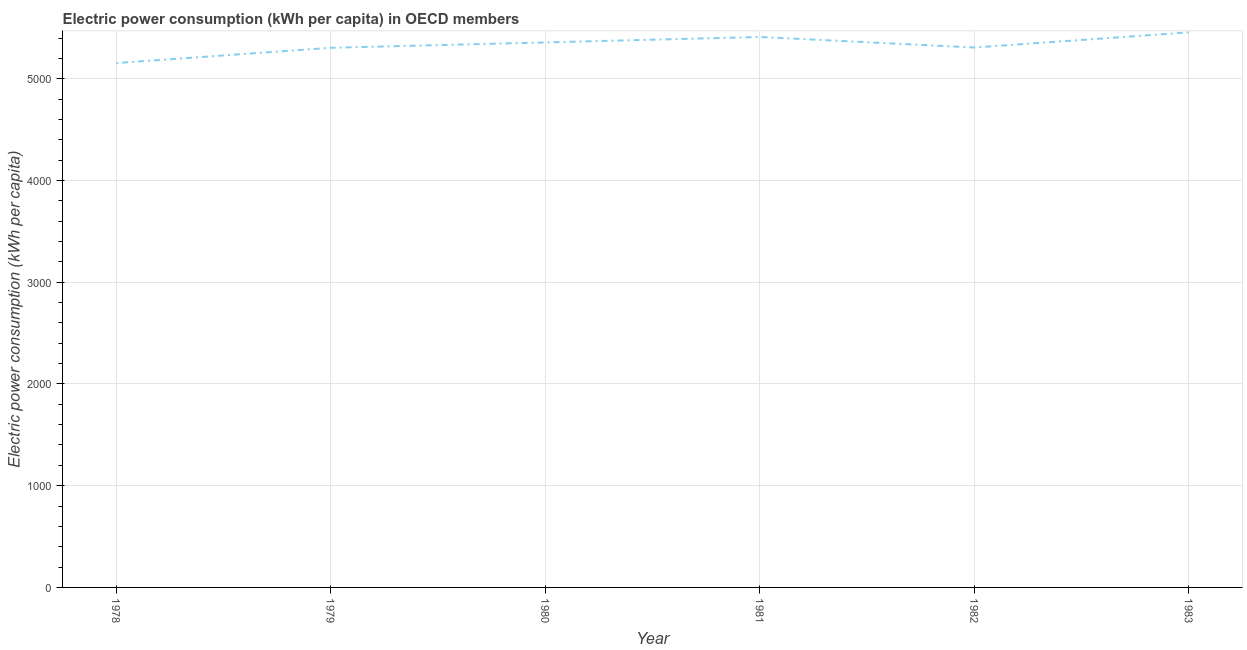What is the electric power consumption in 1982?
Your answer should be very brief. 5307.14. Across all years, what is the maximum electric power consumption?
Provide a succinct answer. 5456.01. Across all years, what is the minimum electric power consumption?
Give a very brief answer. 5153.86. In which year was the electric power consumption maximum?
Keep it short and to the point. 1983. In which year was the electric power consumption minimum?
Make the answer very short. 1978. What is the sum of the electric power consumption?
Ensure brevity in your answer.  3.20e+04. What is the difference between the electric power consumption in 1978 and 1979?
Your response must be concise. -150.58. What is the average electric power consumption per year?
Offer a terse response. 5331.56. What is the median electric power consumption?
Your answer should be very brief. 5332.1. Do a majority of the years between 1979 and 1978 (inclusive) have electric power consumption greater than 1200 kWh per capita?
Provide a succinct answer. No. What is the ratio of the electric power consumption in 1978 to that in 1982?
Keep it short and to the point. 0.97. Is the electric power consumption in 1979 less than that in 1981?
Offer a very short reply. Yes. What is the difference between the highest and the second highest electric power consumption?
Provide a succinct answer. 45.17. What is the difference between the highest and the lowest electric power consumption?
Your answer should be very brief. 302.15. How many years are there in the graph?
Your answer should be compact. 6. What is the difference between two consecutive major ticks on the Y-axis?
Offer a terse response. 1000. Does the graph contain any zero values?
Keep it short and to the point. No. Does the graph contain grids?
Ensure brevity in your answer.  Yes. What is the title of the graph?
Your response must be concise. Electric power consumption (kWh per capita) in OECD members. What is the label or title of the Y-axis?
Your answer should be compact. Electric power consumption (kWh per capita). What is the Electric power consumption (kWh per capita) of 1978?
Keep it short and to the point. 5153.86. What is the Electric power consumption (kWh per capita) of 1979?
Make the answer very short. 5304.44. What is the Electric power consumption (kWh per capita) in 1980?
Provide a succinct answer. 5357.06. What is the Electric power consumption (kWh per capita) in 1981?
Make the answer very short. 5410.84. What is the Electric power consumption (kWh per capita) of 1982?
Offer a very short reply. 5307.14. What is the Electric power consumption (kWh per capita) of 1983?
Keep it short and to the point. 5456.01. What is the difference between the Electric power consumption (kWh per capita) in 1978 and 1979?
Your response must be concise. -150.58. What is the difference between the Electric power consumption (kWh per capita) in 1978 and 1980?
Offer a terse response. -203.19. What is the difference between the Electric power consumption (kWh per capita) in 1978 and 1981?
Provide a short and direct response. -256.98. What is the difference between the Electric power consumption (kWh per capita) in 1978 and 1982?
Ensure brevity in your answer.  -153.28. What is the difference between the Electric power consumption (kWh per capita) in 1978 and 1983?
Your response must be concise. -302.15. What is the difference between the Electric power consumption (kWh per capita) in 1979 and 1980?
Offer a terse response. -52.62. What is the difference between the Electric power consumption (kWh per capita) in 1979 and 1981?
Your response must be concise. -106.4. What is the difference between the Electric power consumption (kWh per capita) in 1979 and 1982?
Provide a short and direct response. -2.7. What is the difference between the Electric power consumption (kWh per capita) in 1979 and 1983?
Provide a succinct answer. -151.57. What is the difference between the Electric power consumption (kWh per capita) in 1980 and 1981?
Ensure brevity in your answer.  -53.78. What is the difference between the Electric power consumption (kWh per capita) in 1980 and 1982?
Provide a succinct answer. 49.91. What is the difference between the Electric power consumption (kWh per capita) in 1980 and 1983?
Offer a very short reply. -98.96. What is the difference between the Electric power consumption (kWh per capita) in 1981 and 1982?
Offer a very short reply. 103.7. What is the difference between the Electric power consumption (kWh per capita) in 1981 and 1983?
Offer a terse response. -45.17. What is the difference between the Electric power consumption (kWh per capita) in 1982 and 1983?
Your answer should be very brief. -148.87. What is the ratio of the Electric power consumption (kWh per capita) in 1978 to that in 1979?
Your answer should be very brief. 0.97. What is the ratio of the Electric power consumption (kWh per capita) in 1978 to that in 1980?
Make the answer very short. 0.96. What is the ratio of the Electric power consumption (kWh per capita) in 1978 to that in 1981?
Your answer should be compact. 0.95. What is the ratio of the Electric power consumption (kWh per capita) in 1978 to that in 1983?
Give a very brief answer. 0.94. What is the ratio of the Electric power consumption (kWh per capita) in 1979 to that in 1980?
Your answer should be compact. 0.99. What is the ratio of the Electric power consumption (kWh per capita) in 1979 to that in 1981?
Your response must be concise. 0.98. What is the ratio of the Electric power consumption (kWh per capita) in 1980 to that in 1983?
Your answer should be very brief. 0.98. 